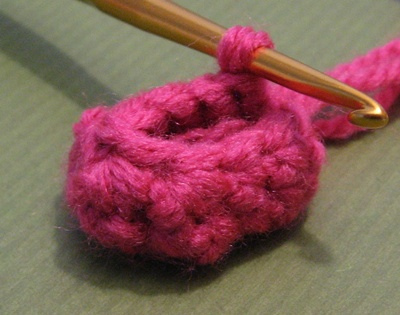<image>
Is there a needle in the yarn? Yes. The needle is contained within or inside the yarn, showing a containment relationship. 